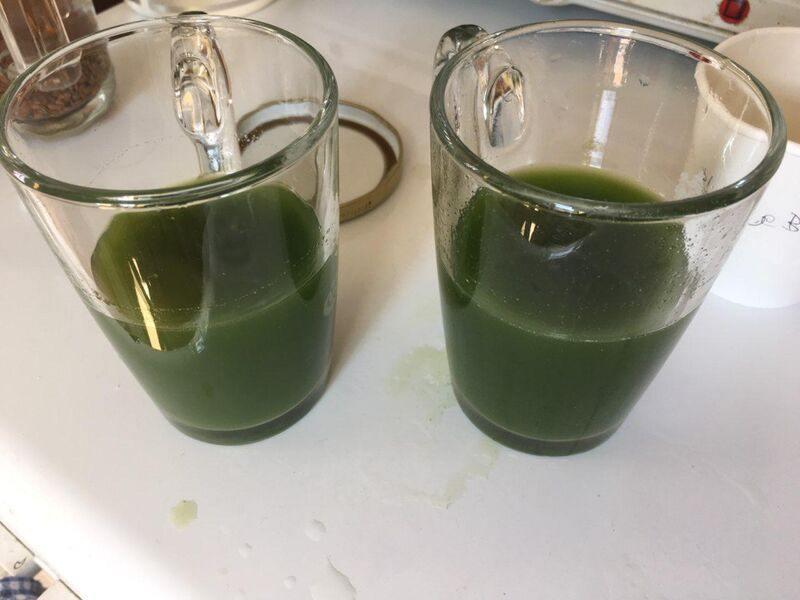What ingredients might be in the green liquid? Based on the color and consistency, the green liquid might contain ingredients such as spinach, kale, or other leafy greens. It might also include some form of liquid base like water, apple juice, or a milk alternative. Other possible ingredients to enhance the flavor could be fruits like apples or bananas, and perhaps a bit of lemon juice for a tangy taste. Could this green liquid have any nutritional benefits? Absolutely! If the green liquid contains leafy greens like spinach or kale, it would be rich in vitamins A, C, and K. These greens are also high in antioxidants, which help protect your cells from damage. Additionally, if it contains fruits, it could provide natural sugars for energy and additional vitamins and nutrients. Such a drink is likely to be low in calories and high in fiber, which can aid digestion and promote a feeling of fullness. What might be the scenario in which this drink is being prepared? This drink could be part of a healthy morning routine. Imagine someone starting their day with a nutritious green smoothie to kickstart their metabolism and infuse their body with essential vitamins and minerals. It might also be prepared after a workout to replenish nutrients and aid in recovery. In either case, it's likely that the person making it is conscious of their health and nutrition. Be creative - could this green liquid have a magical property? In a whimsical world, this green liquid might be a potion concocted by a wizard or witch. It could grant the drinker magical abilities like the power to talk to animals or the ability to grow plants instantly with a touch. Maybe it's a secret brew passed down through generations, with each family member adding a unique ingredient to enhance its mystical properties. Or perhaps, it could be a potion that transforms the drinker into a frog for a limited time, allowing for adventures in the pond before magically reverting back to human form! 